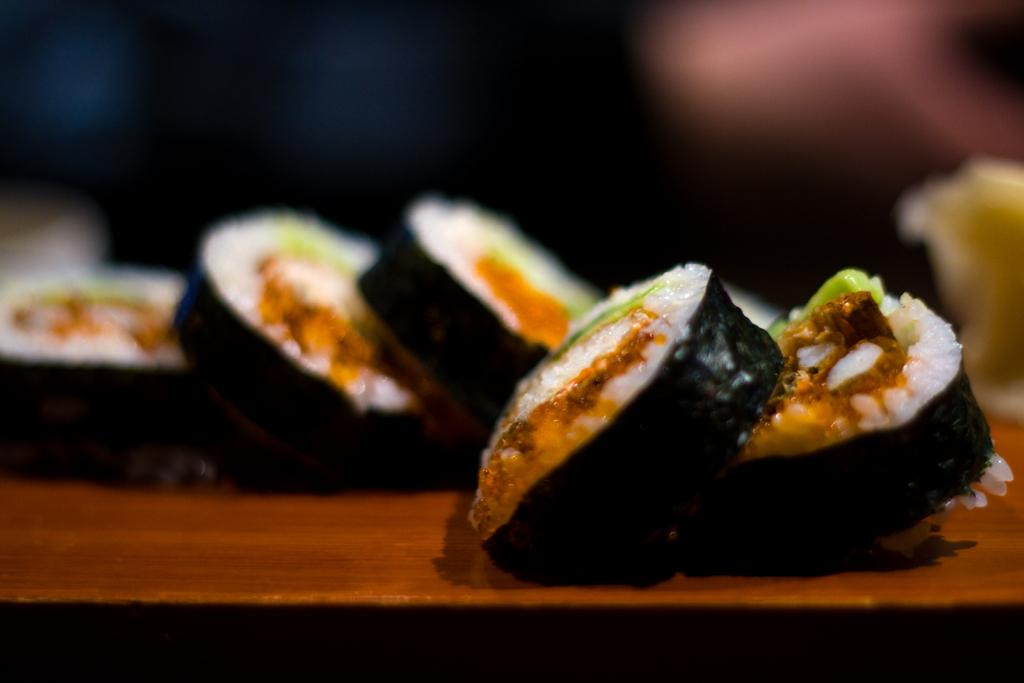What can be seen on the surface in the image? There is food placed on a surface in the image. What theory is being discussed in the notebook held by the uncle in the image? There is no notebook or uncle present in the image, and therefore no theory being discussed. 